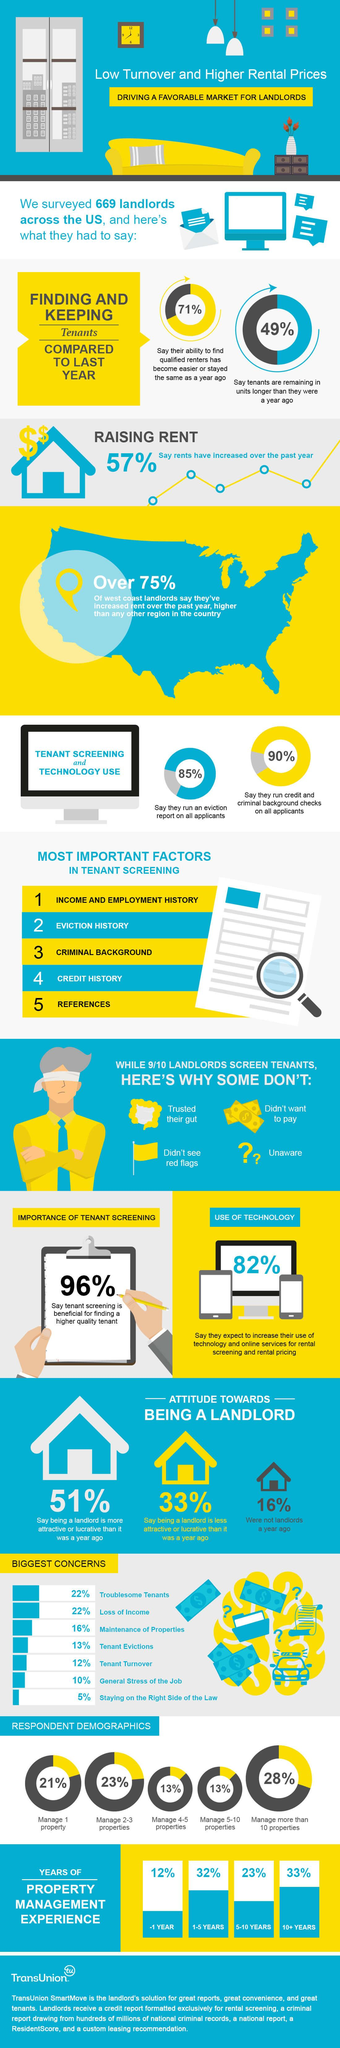Outline some significant characteristics in this image. There are four reasons why landlords may not screen their tenants. There has been no significant increase in rental prices over the past year, as 43% of respondents have reported the same rental rates as before. Last year, 16% of the population did not own a house. The third main concern of landlords is the maintenance of their properties. We do not evict applicants more than 15% of the time. 